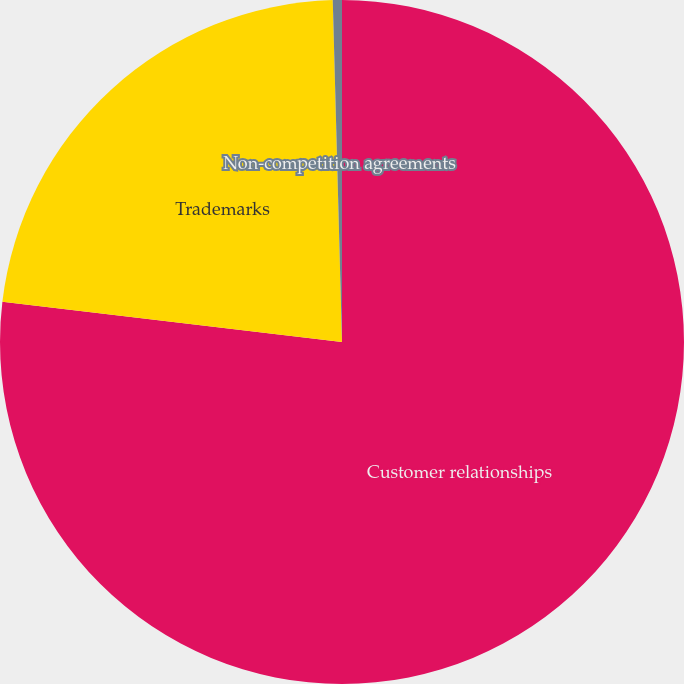Convert chart to OTSL. <chart><loc_0><loc_0><loc_500><loc_500><pie_chart><fcel>Customer relationships<fcel>Trademarks<fcel>Non-competition agreements<nl><fcel>76.88%<fcel>22.69%<fcel>0.43%<nl></chart> 